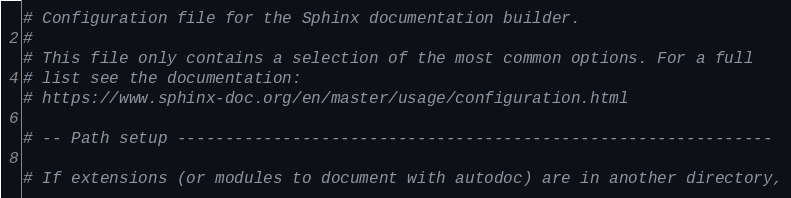Convert code to text. <code><loc_0><loc_0><loc_500><loc_500><_Python_># Configuration file for the Sphinx documentation builder.
#
# This file only contains a selection of the most common options. For a full
# list see the documentation:
# https://www.sphinx-doc.org/en/master/usage/configuration.html

# -- Path setup --------------------------------------------------------------

# If extensions (or modules to document with autodoc) are in another directory,</code> 